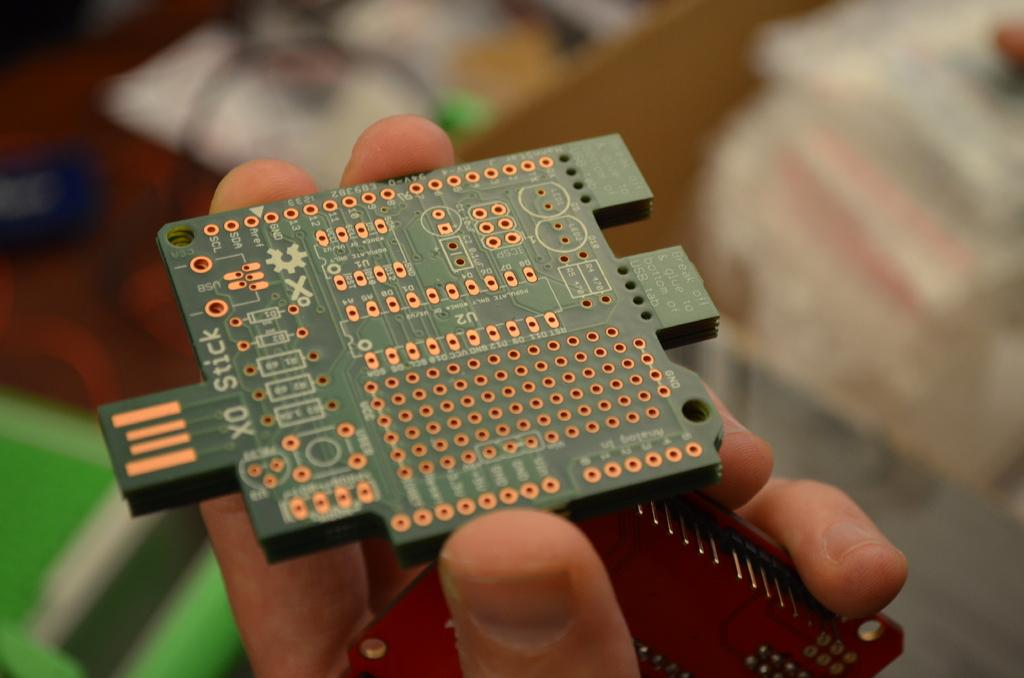What is the main subject of the image? There is a person in the image. What is the person holding in the image? The person is holding circuit boards. Can you describe the background of the image? The background of the image is blurred. What activity is the person participating in on the calendar in the image? There is no calendar present in the image, so it is not possible to determine any activity related to a calendar. 